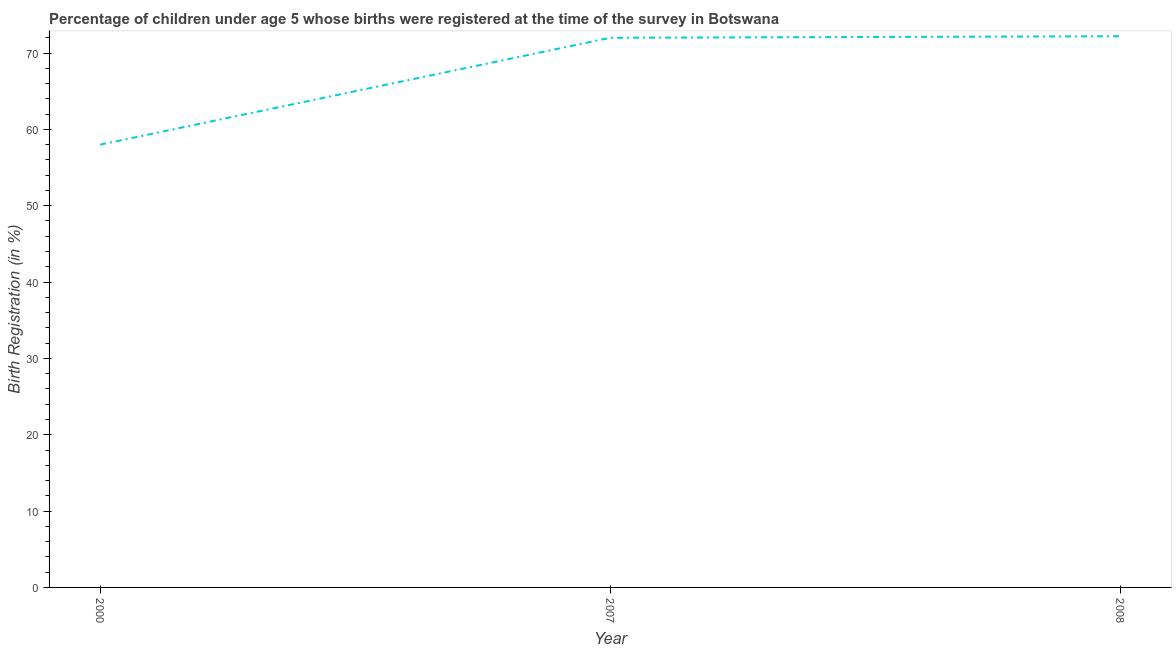What is the birth registration in 2008?
Your response must be concise. 72.2. Across all years, what is the maximum birth registration?
Your response must be concise. 72.2. Across all years, what is the minimum birth registration?
Your answer should be very brief. 58. In which year was the birth registration maximum?
Your answer should be compact. 2008. In which year was the birth registration minimum?
Your response must be concise. 2000. What is the sum of the birth registration?
Keep it short and to the point. 202.2. What is the difference between the birth registration in 2007 and 2008?
Provide a short and direct response. -0.2. What is the average birth registration per year?
Offer a very short reply. 67.4. What is the median birth registration?
Offer a very short reply. 72. In how many years, is the birth registration greater than 62 %?
Keep it short and to the point. 2. Do a majority of the years between 2000 and 2007 (inclusive) have birth registration greater than 40 %?
Keep it short and to the point. Yes. What is the ratio of the birth registration in 2000 to that in 2007?
Offer a terse response. 0.81. Is the birth registration in 2000 less than that in 2007?
Provide a succinct answer. Yes. What is the difference between the highest and the second highest birth registration?
Make the answer very short. 0.2. Is the sum of the birth registration in 2000 and 2008 greater than the maximum birth registration across all years?
Make the answer very short. Yes. What is the difference between the highest and the lowest birth registration?
Offer a terse response. 14.2. In how many years, is the birth registration greater than the average birth registration taken over all years?
Your answer should be compact. 2. Does the birth registration monotonically increase over the years?
Your answer should be very brief. Yes. How many lines are there?
Your response must be concise. 1. What is the difference between two consecutive major ticks on the Y-axis?
Offer a terse response. 10. Are the values on the major ticks of Y-axis written in scientific E-notation?
Provide a short and direct response. No. Does the graph contain any zero values?
Ensure brevity in your answer.  No. What is the title of the graph?
Make the answer very short. Percentage of children under age 5 whose births were registered at the time of the survey in Botswana. What is the label or title of the X-axis?
Provide a succinct answer. Year. What is the label or title of the Y-axis?
Your answer should be very brief. Birth Registration (in %). What is the Birth Registration (in %) in 2008?
Provide a succinct answer. 72.2. What is the difference between the Birth Registration (in %) in 2000 and 2007?
Give a very brief answer. -14. What is the ratio of the Birth Registration (in %) in 2000 to that in 2007?
Your answer should be compact. 0.81. What is the ratio of the Birth Registration (in %) in 2000 to that in 2008?
Offer a very short reply. 0.8. What is the ratio of the Birth Registration (in %) in 2007 to that in 2008?
Keep it short and to the point. 1. 